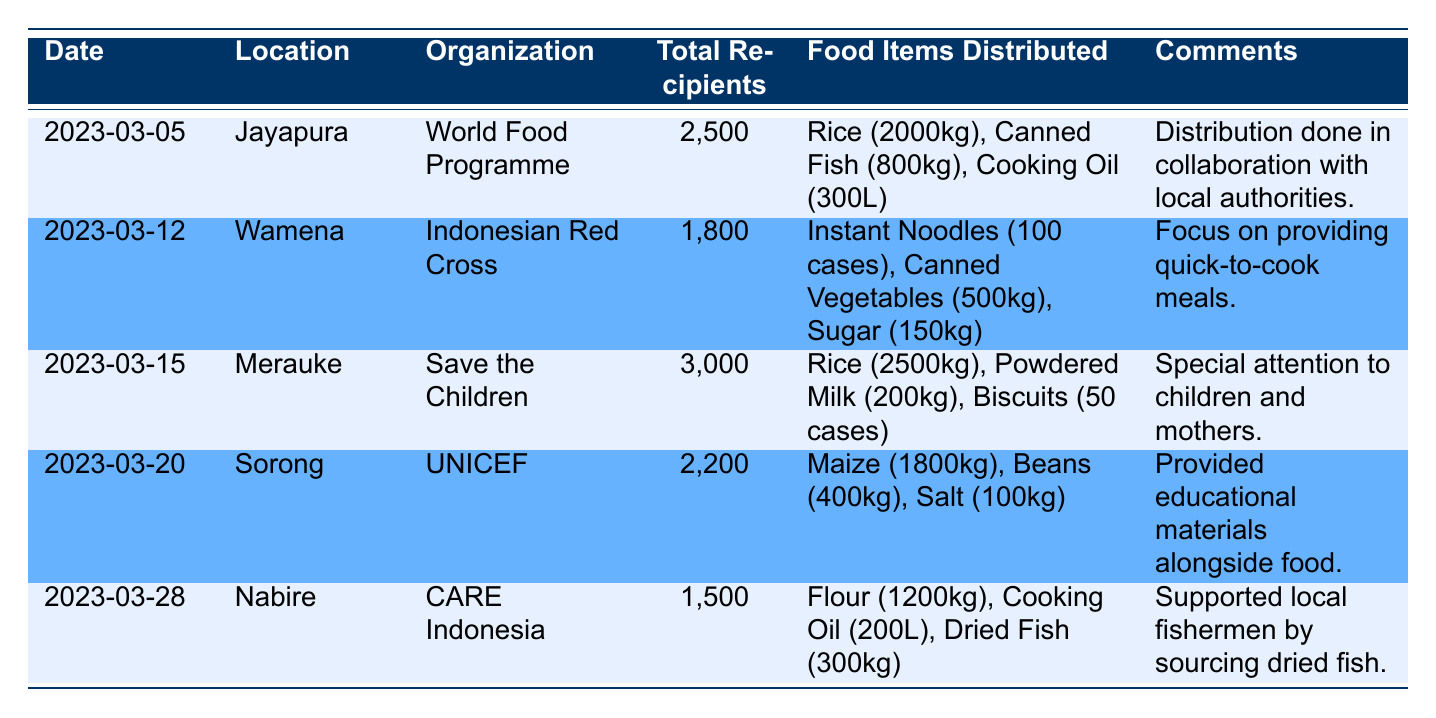What was the total number of food recipients in Merauke? In the row for Merauke, the total number of recipients is listed as 3000.
Answer: 3000 Which organization distributed food aid in Wamena? Looking at the Wamena row, the organization that distributed food aid there is the Indonesian Red Cross.
Answer: Indonesian Red Cross What were the food items distributed by World Food Programme? In the Jayapura row under the organization World Food Programme, the distributed items were Rice (2000kg), Canned Fish (800kg), Cooking Oil (300L).
Answer: Rice (2000kg), Canned Fish (800kg), Cooking Oil (300L) Which location received food aid on March 20? The row for the date March 20 shows that the location which received food aid is Sorong.
Answer: Sorong How many total food recipients were served by UNICEF? The row for UNICEF indicates that they served a total of 2200 recipients in Sorong.
Answer: 2200 Which food item had the highest quantity distributed in the data? To find the highest quantity, we need to compare all food distributions: 2500kg Rice (Merauke), 2000kg Rice (Jayapura), 1800kg Maize (Sorong), etc. The highest is 2500kg Rice from Merauke.
Answer: 2500kg Rice Did CARE Indonesia distribute more cooking oil than the World Food Programme? In the CARE Indonesia row, the quantity is Cooking Oil (200L) and in World Food Programme it is Cooking Oil (300L). Since 300L is more than 200L, the statement is false.
Answer: No What is the total quantity of Rice distributed across all locations? The table lists: Jayapura 2000kg, Merauke 2500kg. Adding those gives 2000 + 2500 = 4500kg. Other locations did not distribute Rice.
Answer: 4500kg Did any organization provide food aid specifically for children and mothers? The comments section for Save the Children note that they gave special attention to children and mothers during their distribution.
Answer: Yes 